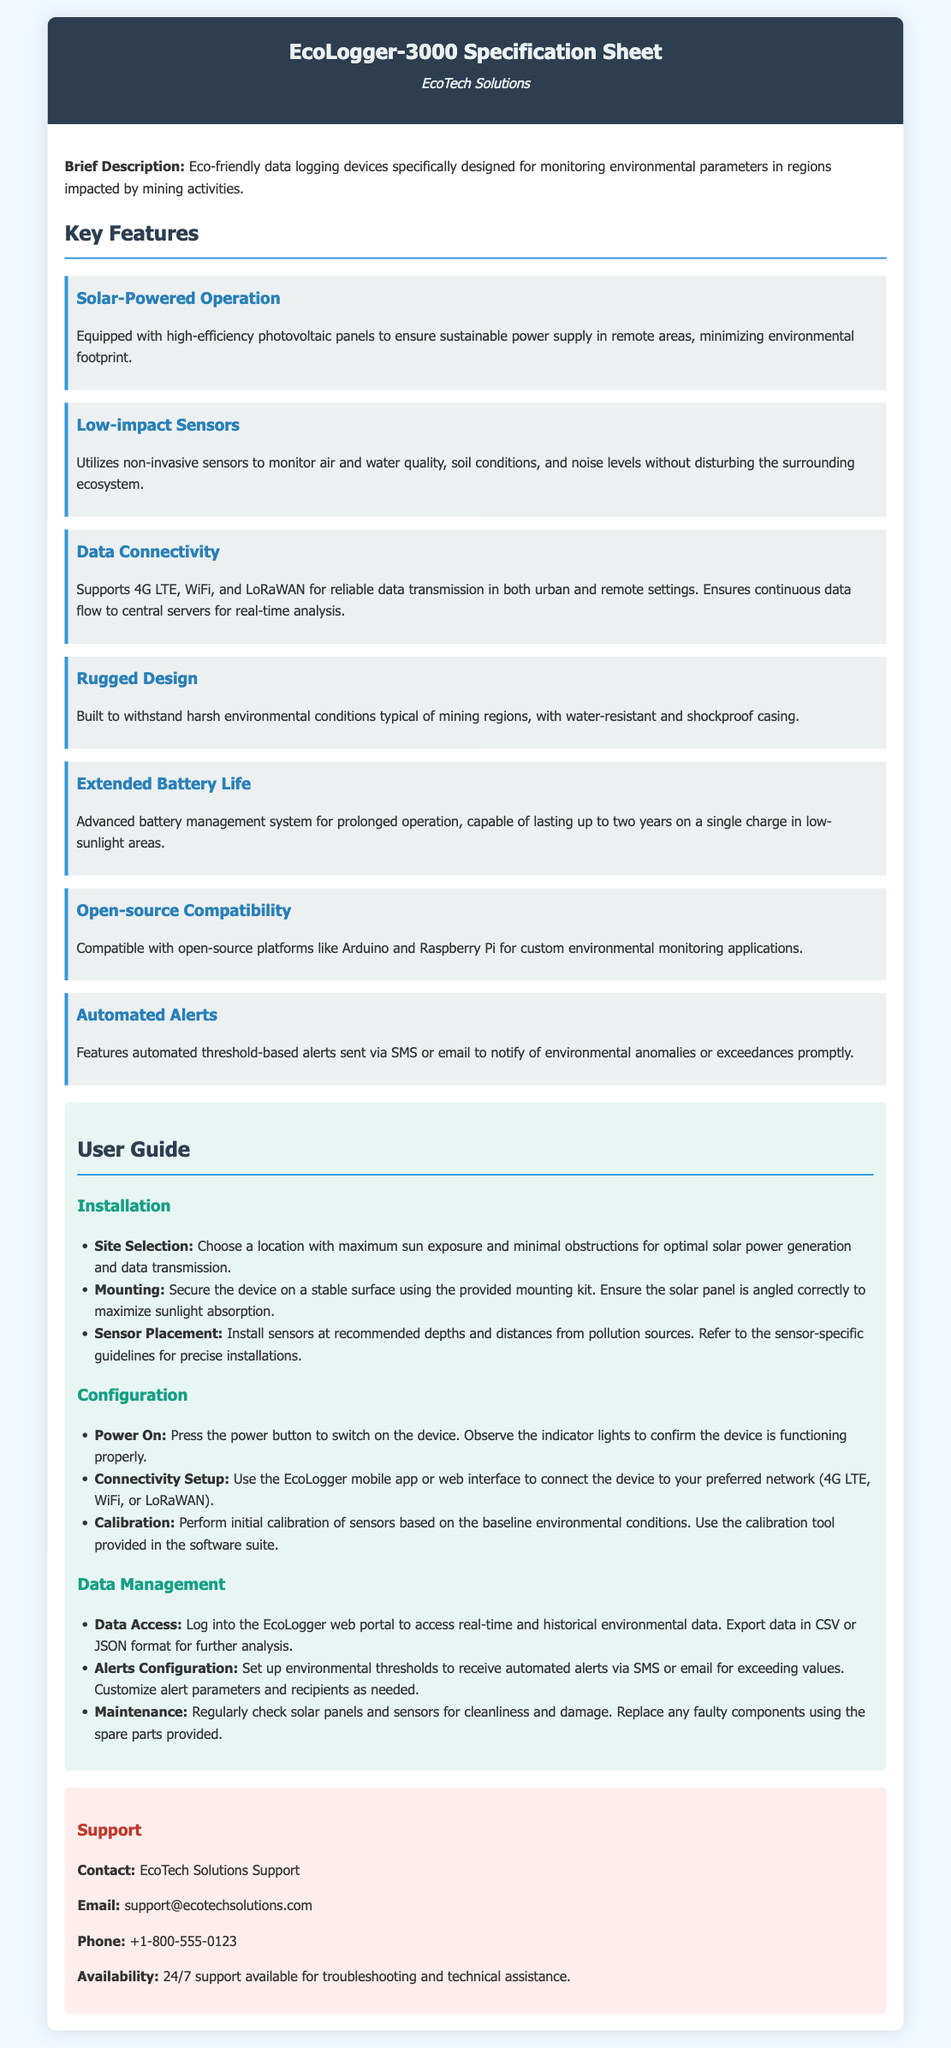What is the model name of the device? The model name of the device is clearly indicated at the beginning of the document.
Answer: EcoLogger-3000 Who is the manufacturer? The manufacturer is identified in the header section of the document.
Answer: EcoTech Solutions What type of power supply does the device use? The document specifies the type of power supply in the Key Features section.
Answer: Solar-Powered Operation What is the expected battery life? The document mentions the battery life in the Extended Battery Life feature.
Answer: Up to two years What environmental parameters does the device monitor? The information about monitored parameters is found in the Low-impact Sensors feature.
Answer: Air and water quality, soil conditions, noise levels What type of casing does the EcoLogger-3000 have? The type of casing is mentioned in the Rugged Design feature.
Answer: Water-resistant and shockproof casing What is needed for initial calibration? The calibration requirement is detailed in the Configuration section of the User Guide.
Answer: Calibration tool provided in the software suite How can alerts be received? The method for receiving alerts is described in the Automated Alerts feature.
Answer: SMS or email What is the contact email for support? The contact email is listed in the Support section of the document.
Answer: support@ecotechsolutions.com 